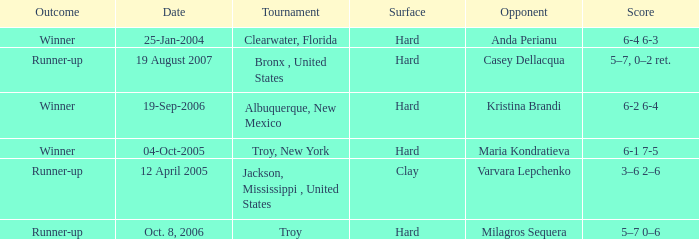Where was the tournament played on Oct. 8, 2006? Troy. 